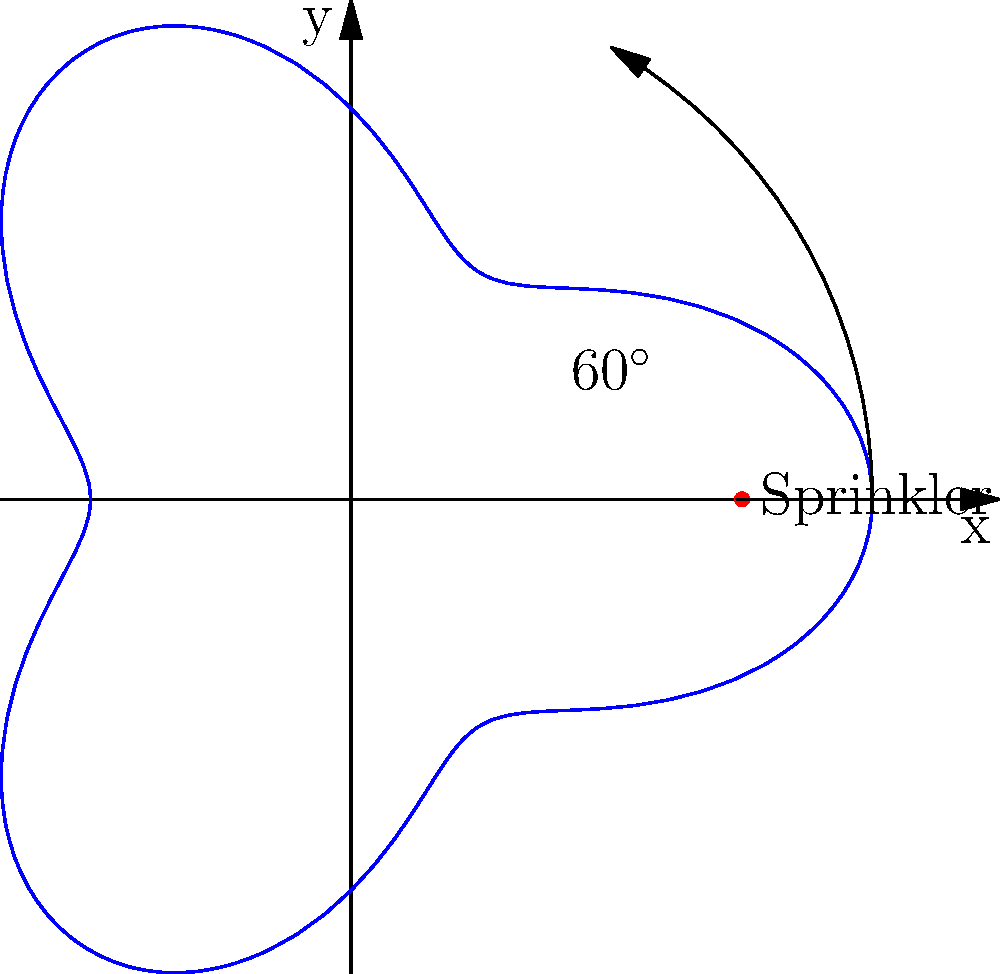A local park has installed a new sprinkler system with a unique coverage pattern. The range of the sprinkler in meters is given by the polar equation $r = 15 + 5\cos(3\theta)$, where $\theta$ is measured in radians. What is the maximum range of the sprinkler, and in which direction(s) does this maximum occur? To solve this problem, we need to follow these steps:

1) The range of the sprinkler is given by $r = 15 + 5\cos(3\theta)$.

2) The maximum range will occur when $\cos(3\theta)$ is at its maximum value, which is 1.

3) When $\cos(3\theta) = 1$, the range equation becomes:
   $r_{max} = 15 + 5(1) = 20$ meters

4) To find the direction(s), we need to solve $\cos(3\theta) = 1$:
   $3\theta = 0, 2\pi, 4\pi, ...$
   $\theta = 0, \frac{2\pi}{3}, \frac{4\pi}{3}, 2\pi$

5) Converting to degrees:
   $\theta = 0°, 120°, 240°, 360°$

Therefore, the maximum range is 20 meters and it occurs in three directions: 0° (or 360°), 120°, and 240° from the positive x-axis.
Answer: 20 meters; at 0°, 120°, and 240° 